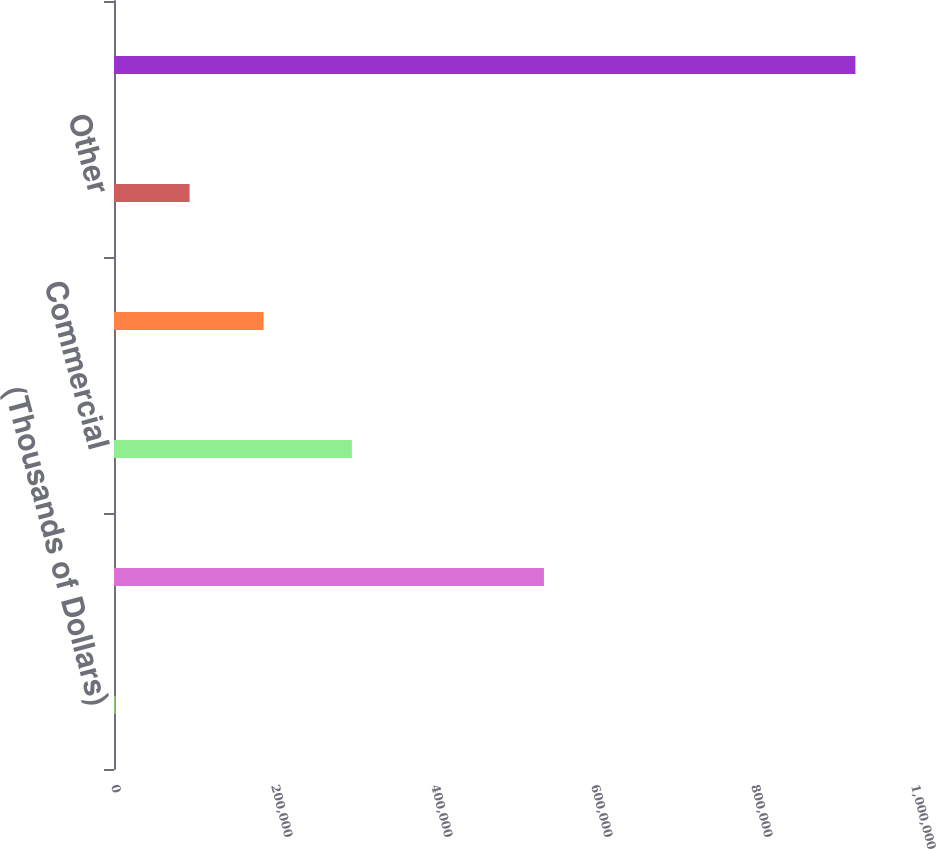Convert chart. <chart><loc_0><loc_0><loc_500><loc_500><bar_chart><fcel>(Thousands of Dollars)<fcel>Residential<fcel>Commercial<fcel>Industrial<fcel>Other<fcel>Total Retail Electric Revenues<nl><fcel>2017<fcel>537439<fcel>297342<fcel>186964<fcel>94490.5<fcel>926752<nl></chart> 